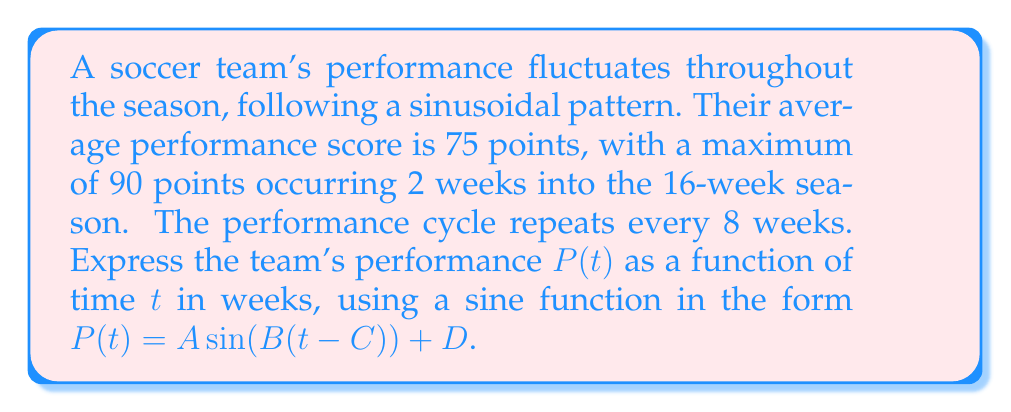Help me with this question. Let's approach this step-by-step:

1) The general form of the function is $P(t) = A \sin(B(t-C)) + D$, where:
   $A$ is the amplitude
   $B$ is related to the period
   $C$ is the horizontal shift
   $D$ is the vertical shift

2) Calculate $D$ (vertical shift):
   $D$ is the average performance score, so $D = 75$

3) Calculate $A$ (amplitude):
   Amplitude = (Maximum - Average) = 90 - 75 = 15

4) Calculate $B$ (related to period):
   Period = 8 weeks
   $B = \frac{2\pi}{\text{period}} = \frac{2\pi}{8} = \frac{\pi}{4}$

5) Calculate $C$ (horizontal shift):
   The maximum occurs 2 weeks into the season.
   For a sine function, this is a quarter of the period after the start.
   So, $C = 2 - \frac{8}{4} = 0$

6) Putting it all together:
   $P(t) = 15 \sin(\frac{\pi}{4}(t-0)) + 75$

7) Simplify:
   $P(t) = 15 \sin(\frac{\pi}{4}t) + 75$
Answer: $P(t) = 15 \sin(\frac{\pi}{4}t) + 75$ 